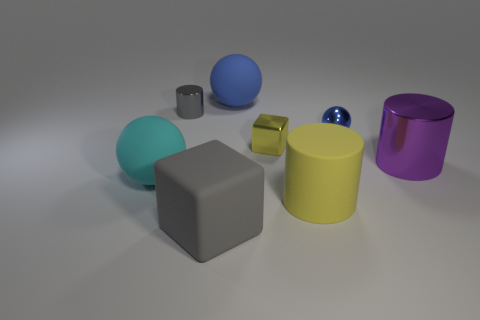Can you tell me the colors of the objects in the counterclockwise order starting with the big cube? Starting with the large cube and moving in a counterclockwise direction, the colors are gray, aqua, silver, gold, sapphire, lemon, and finally violet for the cylinder.  Which objects are the same shape? In the image, there are two types of shapes – cubes and cylinders. There are two cubes; one is large and gray, and the other is much smaller and gold-colored. There are also three cylinders, varying in size and color: aqua, lemon, and violet. 